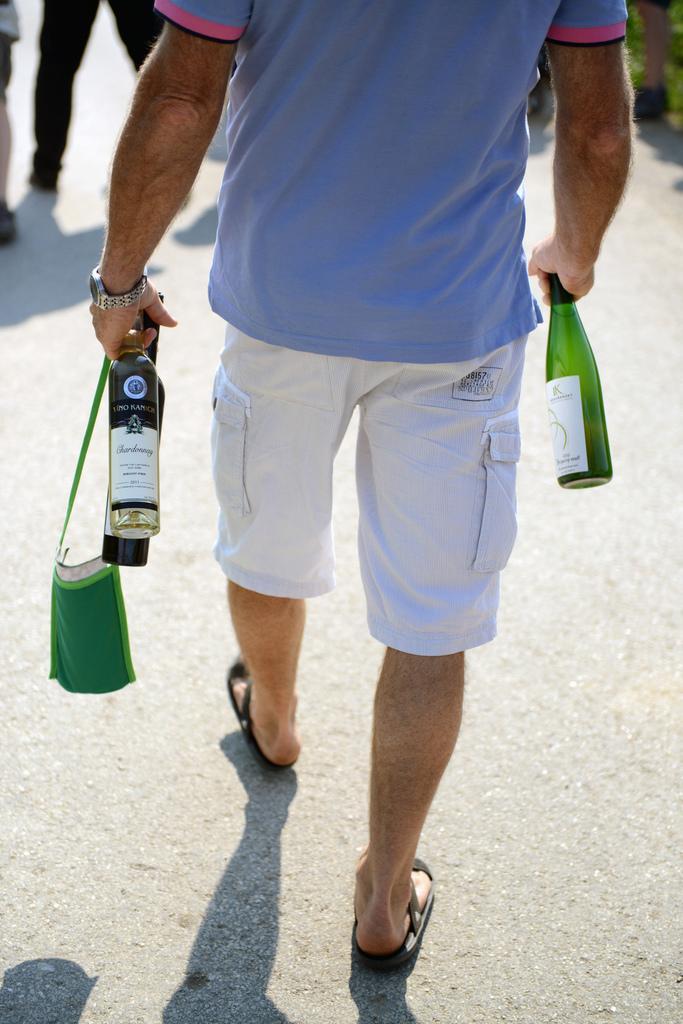How would you summarize this image in a sentence or two? This picture shows a man holding bottles in his hand hand walking on the road 